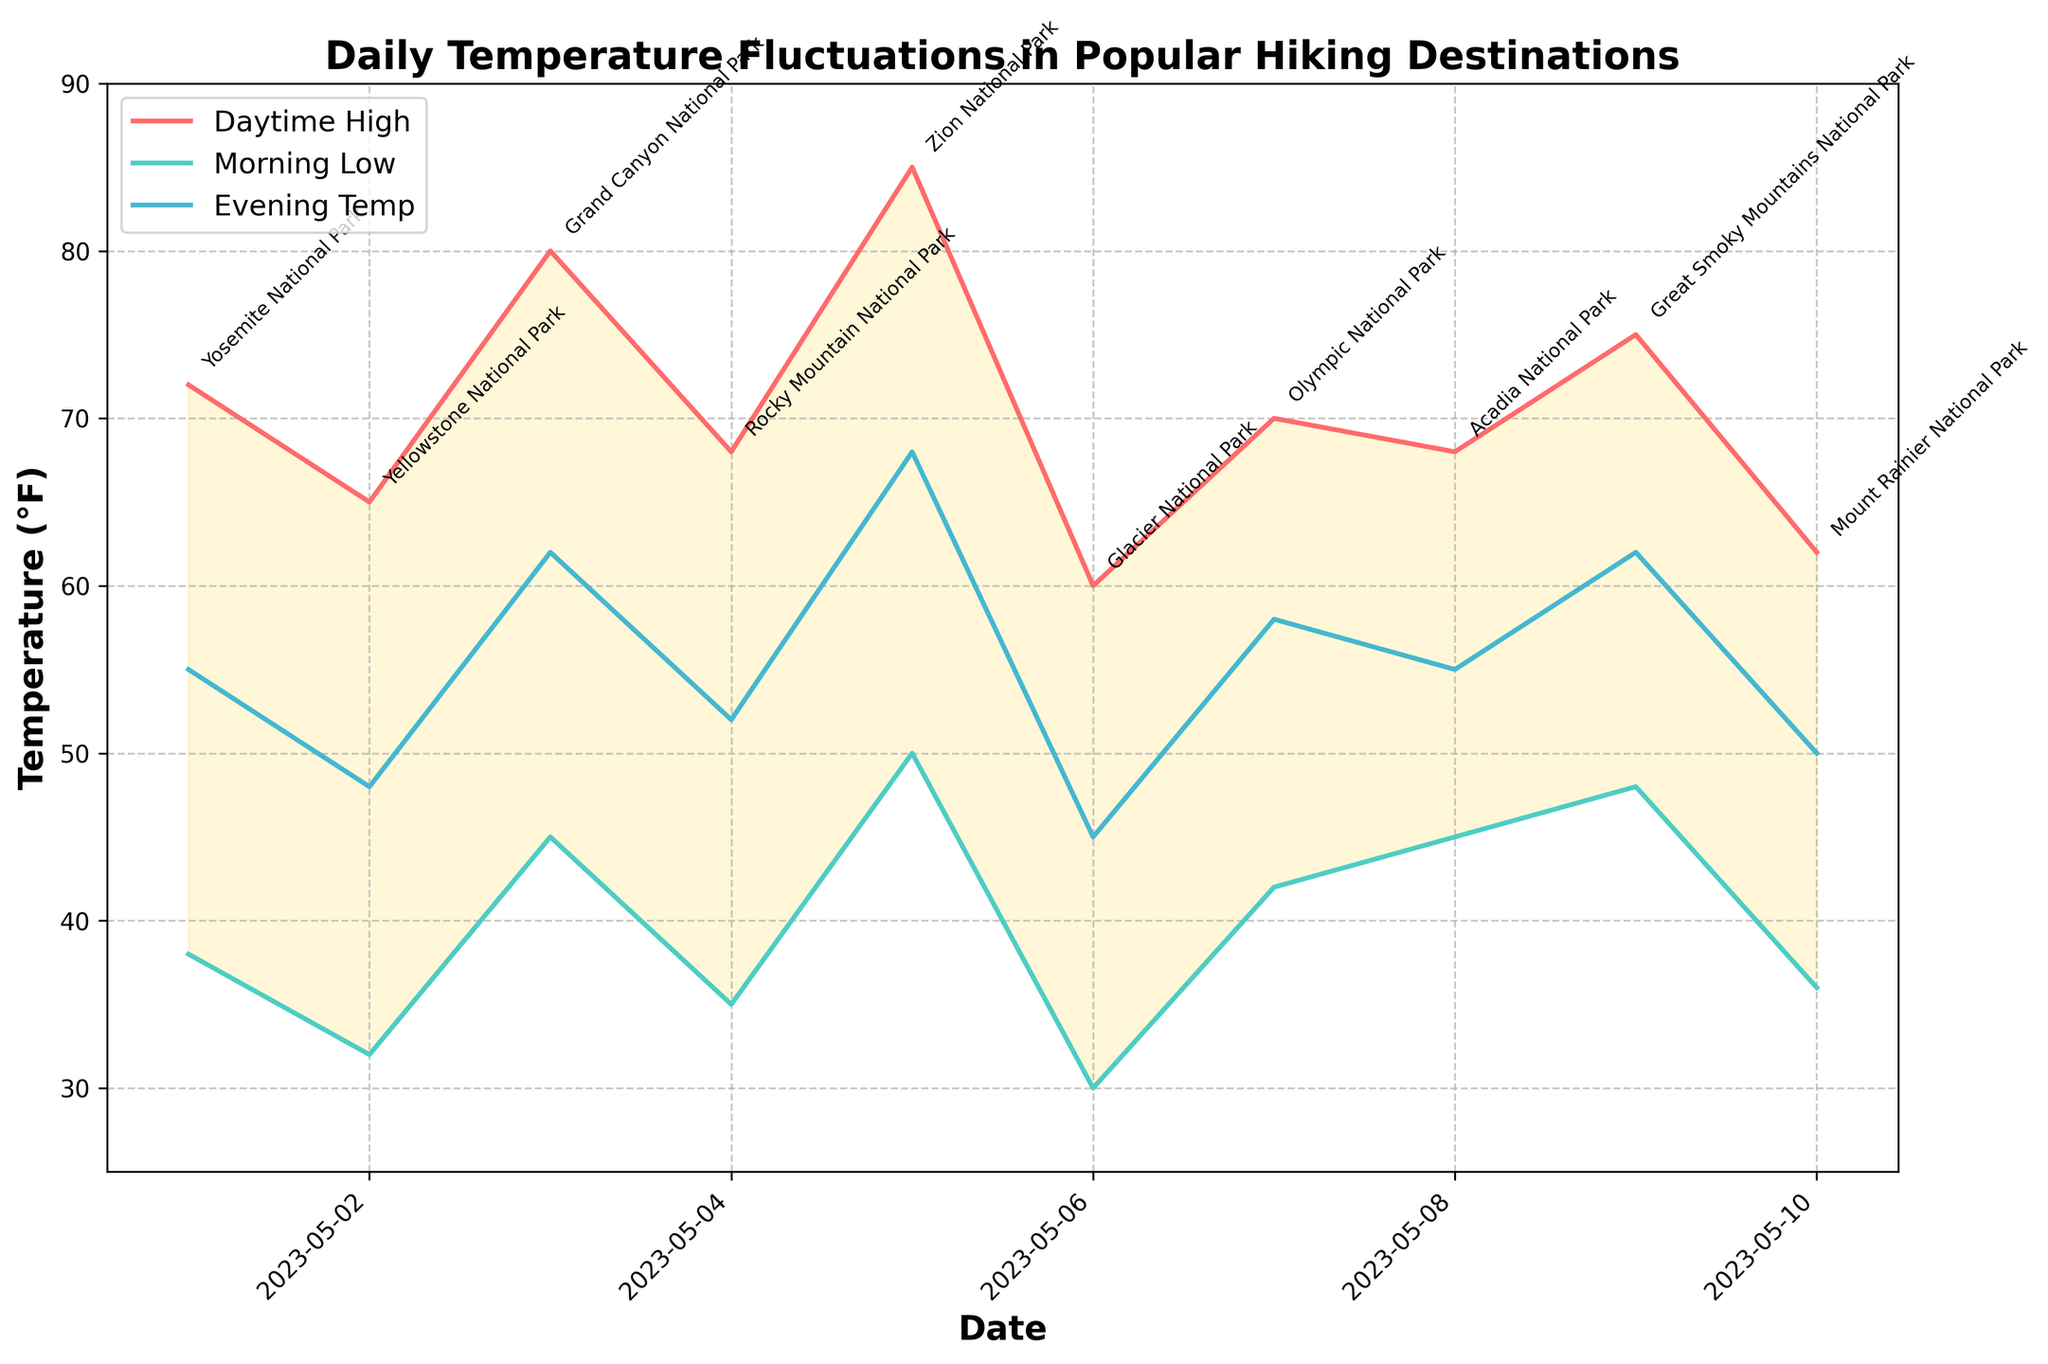What is the highest daytime temperature recorded and at which location? By looking at the line representing daytime highs, the highest point is at May 5th. The annotation next to that point says "Zion National Park" and the temperature is 85°F
Answer: 85°F at Zion National Park How do morning low temperatures typically compare to evening temperatures? Across most data points, morning low temperatures are generally lower than evening temperatures, as seen by comparing the two lines representing these temperatures.
Answer: Morning lows are generally lower than evening temperatures Which location has the lowest recorded morning low temperature and what is that temperature? The lowest morning low temperature is observed at May 6th. The annotation next to that point is "Glacier National Park" with a morning low of 30°F.
Answer: 30°F at Glacier National Park How many days had a morning low temperature above 40°F? By counting the markers for morning low temperatures, we can see there are six days where the temperature is above 40°F (May 1, May 3, May 5, May 7, May 8, and May 9).
Answer: 6 days Which locations had evening temperatures that were closer to their daytime highs than their morning lows? By comparing the proximity of the evening temperature line to the daytime high and morning low lines, Zion National Park (May 5) and Great Smoky Mountains National Park (May 9) exhibit this characteristic.
Answer: Zion National Park and Great Smoky Mountains National Park Calculate the average daytime high temperature for the days shown. Sum of daytime highs: 72 + 65 + 80 + 68 + 85 + 60 + 70 + 68 + 75 + 62 = 705. Divided by 10 days gives an average of 705/10 = 70.5°F.
Answer: 70.5°F Which two locations have the smallest difference between their morning low and daytime high temperatures on a single day? Subtracting morning lows from daytime highs for each day shows the smallest differences at Olympic National Park (70 - 42 = 28) and Mount Rainier National Park (62 - 36 = 26).
Answer: Olympic National Park and Mount Rainier National Park What was the temperature range (difference between daytime high and morning low) for Yosemite National Park on May 1st? The morning low was 38°F and the daytime high was 72°F; the difference is 72 - 38 = 34°F.
Answer: 34°F What trend, if any, can be observed in the daytime high temperatures over the date range? The temperatures fluctuate rather than showing any clear upward or downward trend, indicating varied weather across the different locations.
Answer: No clear trend Compare the temperature fluctuations of Grand Canyon National Park (May 3) and Rocky Mountain National Park (May 4). Which had greater fluctuations? The fluctuation (difference between daytime high and morning low) for Grand Canyon National Park on May 3 is 80 - 45 = 35°F. For Rocky Mountain National Park on May 4 it is 68 - 35 = 33°F. Grand Canyon National Park had greater fluctuations.
Answer: Grand Canyon National Park 